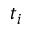Convert formula to latex. <formula><loc_0><loc_0><loc_500><loc_500>t _ { i }</formula> 